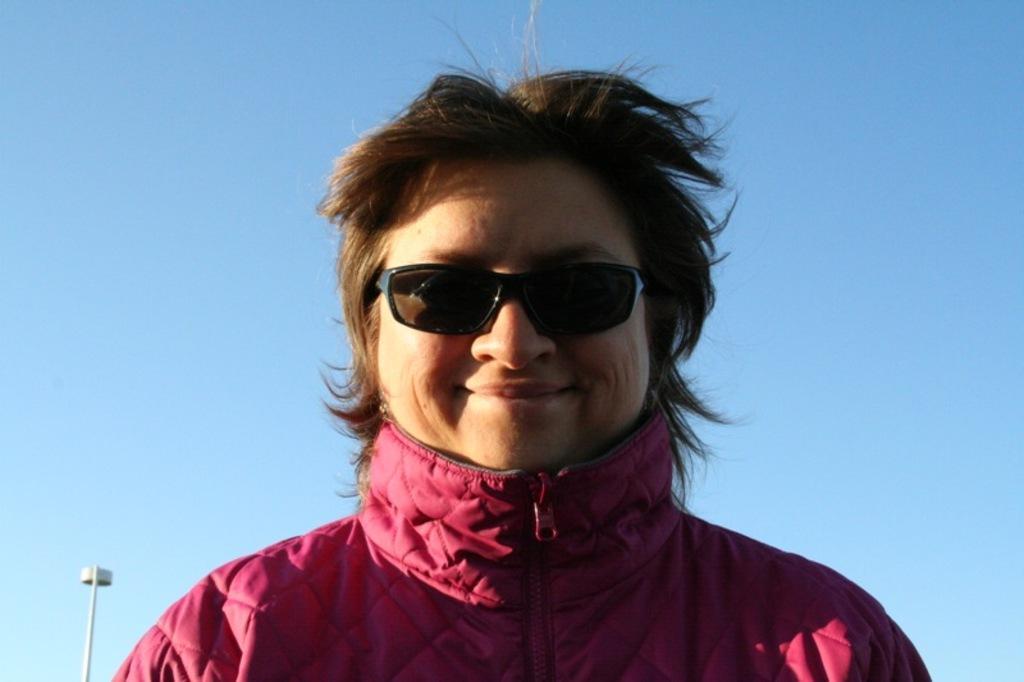How would you summarize this image in a sentence or two? In this picture in the front there is a person smiling, wearing a black colour goggles. In the background there is a pole which is white in colour. 